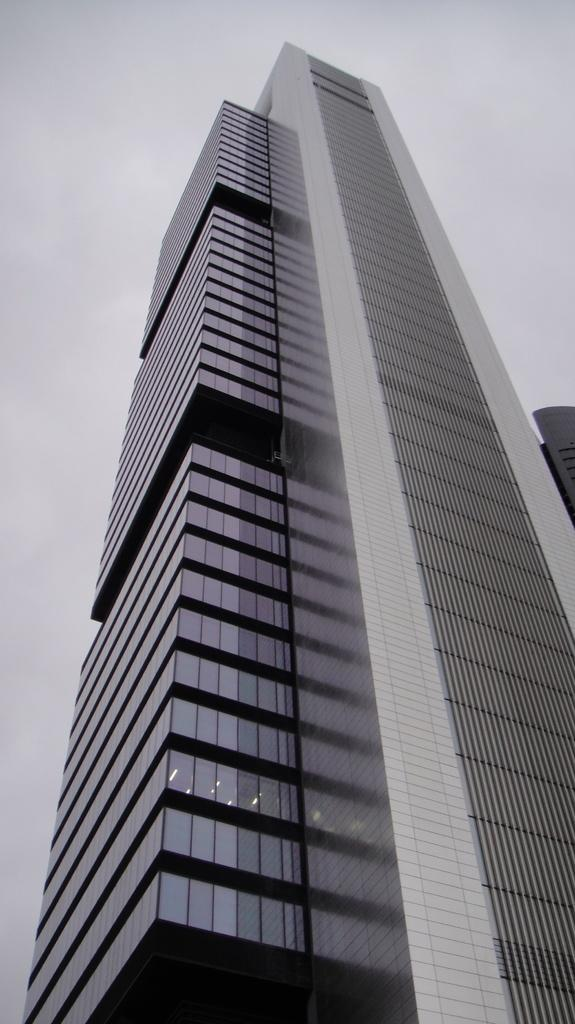What is the main structure in the center of the image? There is a skyscraper in the center of the image. What can be seen at the top of the image? The sky is visible at the top of the image. What type of yarn is being used to create the apparel on the horses in the image? There are no horses or apparel present in the image, so there is no yarn being used. 